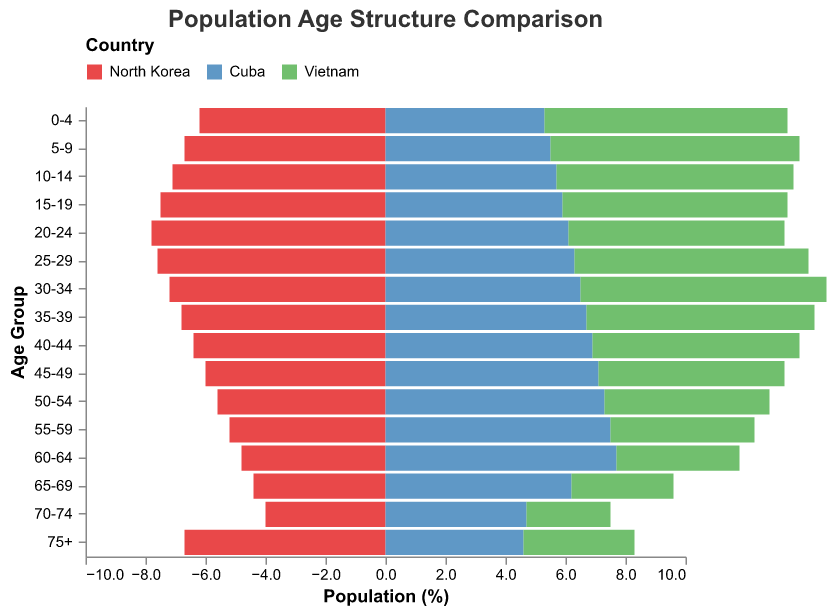What is the title of the figure? The title of the figure is located at the top and usually describes the main subject of the visualization. In this case, the title provides a clear indication of what the figure is about.
Answer: Population Age Structure Comparison Which age group has the highest population percentage in North Korea? To identify the age group with the highest population percentage in North Korea, locate the segment with the longest bar extending to the left.
Answer: 20-24 How many age groups are represented in the figure? Count the different age groups listed on the y-axis.
Answer: 16 What is the population percentage of the age group 40-44 for Cuba? Find the bar representing Cuba for the age group 40-44 and read its length/value.
Answer: 6.9% How does the population percentage of the age group 0-4 compare between North Korea and Vietnam? Locate the bars for the age group 0-4 for both North Korea and Vietnam and compare the lengths/values.
Answer: Vietnam has a higher percentage (8.1% vs. 6.2%) In which age group does Cuba have the highest population percentage? To determine the age group where Cuba has the highest percentage, look for the longest bar in blue that extends to the right.
Answer: 60-64 What is the difference in population percentage for the age group 55-59 between North Korea and Cuba? Calculate the difference by subtracting North Korea's value from Cuba's value for the age group 55-59.
Answer: 2.3% Which age group in Vietnam shows a significant drop in population percentage compared to the previous group? Identify an age group where the green bar length noticeably decreases compared to the previous age group.
Answer: 60-64 What percentage of the population is aged 75+ in North Korea? Find the bar for the age group 75+ in North Korea and note its length/value.
Answer: 6.7% For the age group 30-34, is the population percentage higher in Vietnam or Cuba? Compare the lengths of the bars for the age group 30-34 in both Vietnam and Cuba.
Answer: Vietnam 